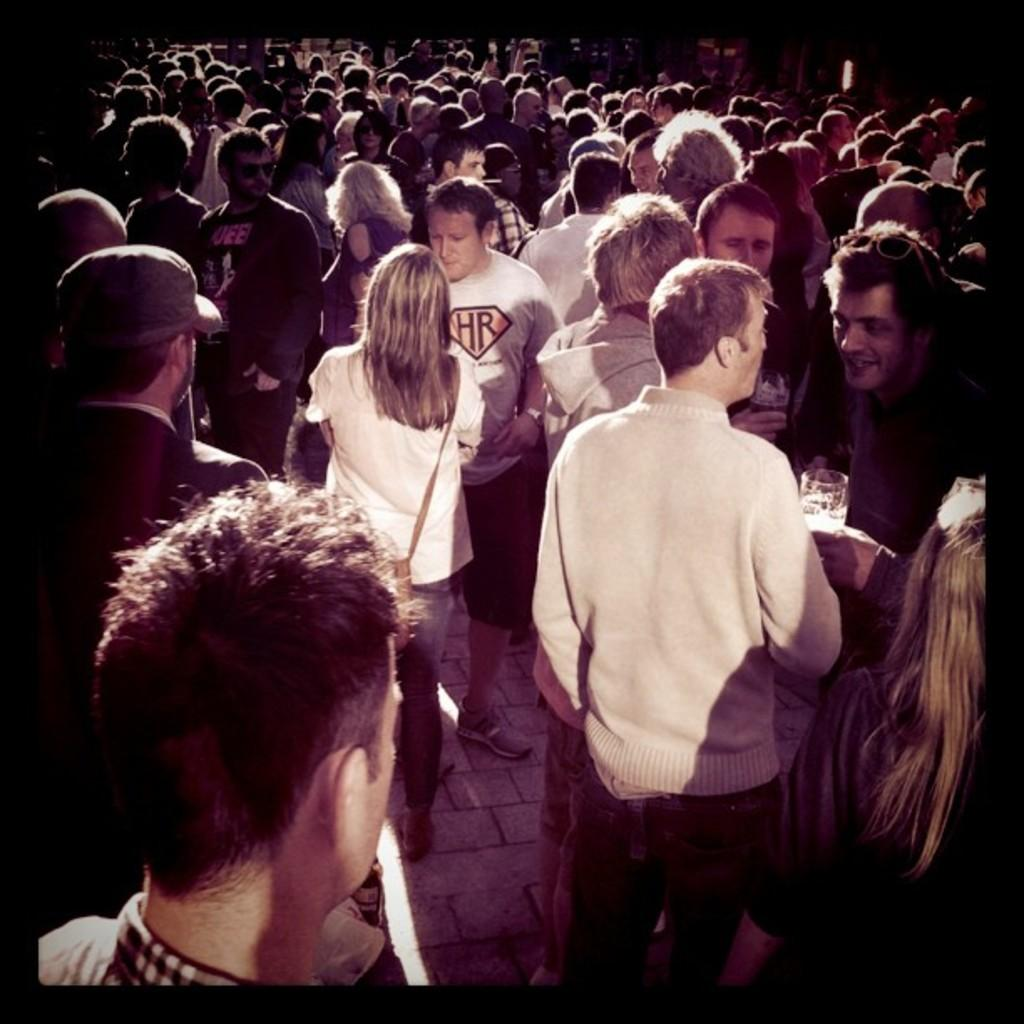How many people are in the image? There are persons standing in the image, but the exact number cannot be determined without more information. What are the people in the image doing? The provided facts do not specify what the people are doing, so we cannot answer this question definitively. Can you describe the setting or environment in the image? The provided facts do not give any information about the setting or environment, so we cannot answer this question definitively. What type of zinc is being used by the people in the image? There is no mention of zinc in the image, so we cannot answer this question definitively. 